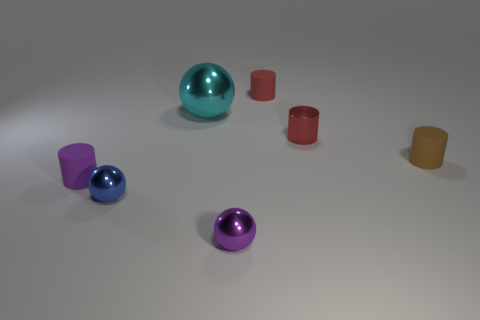How many objects are depicted in this image, and can you describe their colors? There are five objects in the image. Starting from the left, there is a purple cylinder, a blue sphere, a red cylinder, a larger teal sphere, and finally a smaller mustard yellow cylinder. 